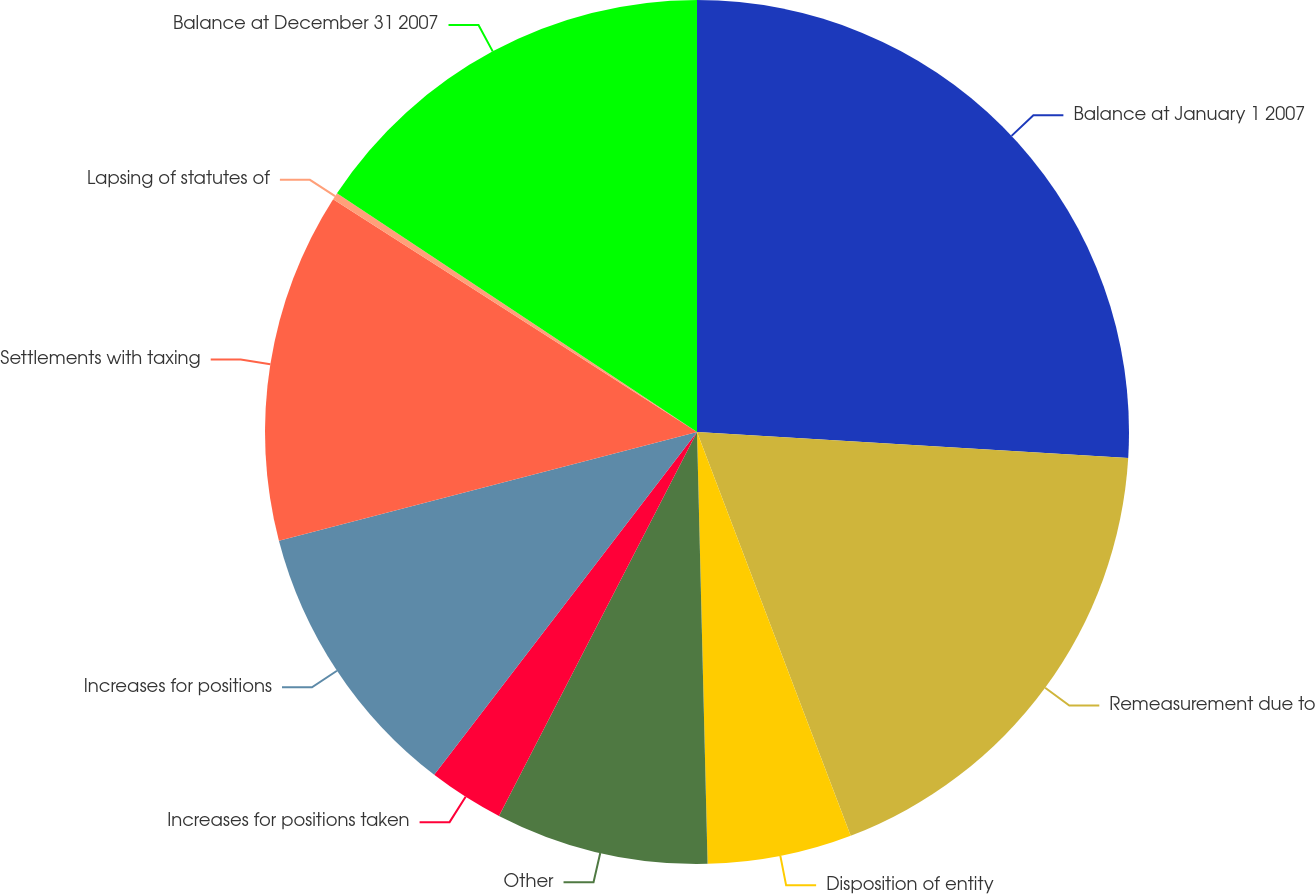Convert chart. <chart><loc_0><loc_0><loc_500><loc_500><pie_chart><fcel>Balance at January 1 2007<fcel>Remeasurement due to<fcel>Disposition of entity<fcel>Other<fcel>Increases for positions taken<fcel>Increases for positions<fcel>Settlements with taxing<fcel>Lapsing of statutes of<fcel>Balance at December 31 2007<nl><fcel>25.96%<fcel>18.25%<fcel>5.4%<fcel>7.97%<fcel>2.83%<fcel>10.54%<fcel>13.11%<fcel>0.26%<fcel>15.68%<nl></chart> 